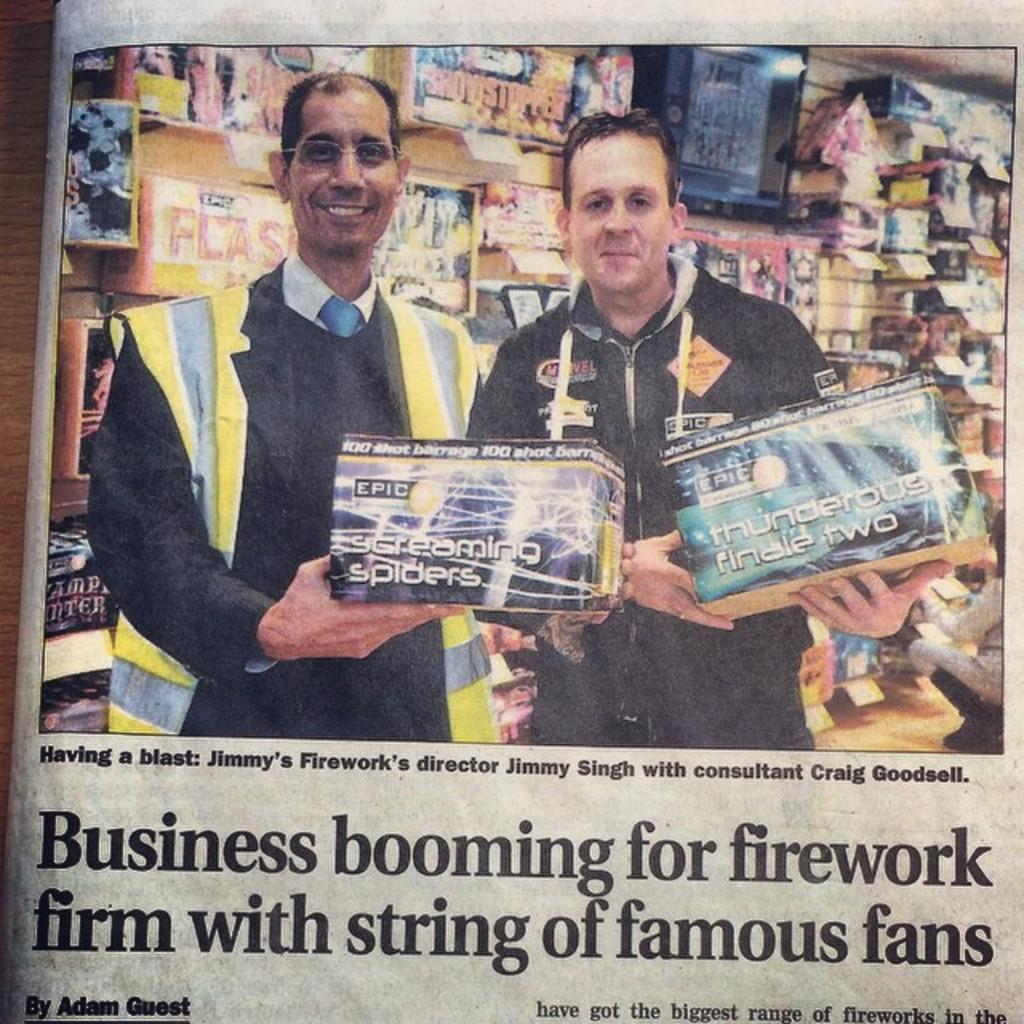What is the main object in the image? The main object in the image is a newspaper. What can be seen in the picture on the newspaper? There is a picture of a woman standing and holding an object in their hands. What is the woman holding in the picture? The woman is holding toys in the picture. What else can be found on the newspaper besides the picture? There are letters on the newspaper. Can you tell me how many deer are visible in the image? There are no deer present in the image; it features a picture of a woman holding toys on a newspaper. Is there a door visible in the image? There is no door present in the image; it features a picture of a woman holding toys on a newspaper. 